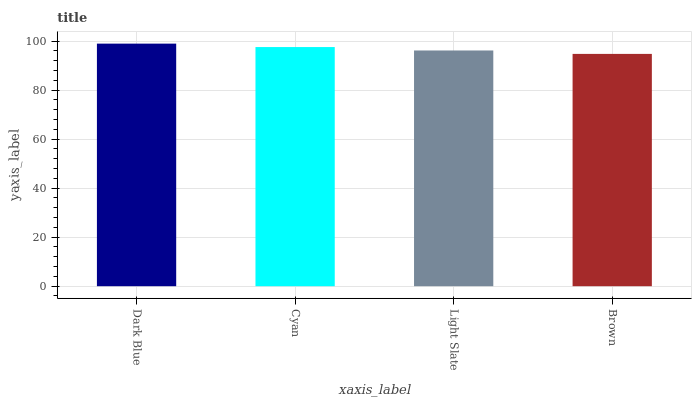Is Brown the minimum?
Answer yes or no. Yes. Is Dark Blue the maximum?
Answer yes or no. Yes. Is Cyan the minimum?
Answer yes or no. No. Is Cyan the maximum?
Answer yes or no. No. Is Dark Blue greater than Cyan?
Answer yes or no. Yes. Is Cyan less than Dark Blue?
Answer yes or no. Yes. Is Cyan greater than Dark Blue?
Answer yes or no. No. Is Dark Blue less than Cyan?
Answer yes or no. No. Is Cyan the high median?
Answer yes or no. Yes. Is Light Slate the low median?
Answer yes or no. Yes. Is Brown the high median?
Answer yes or no. No. Is Cyan the low median?
Answer yes or no. No. 